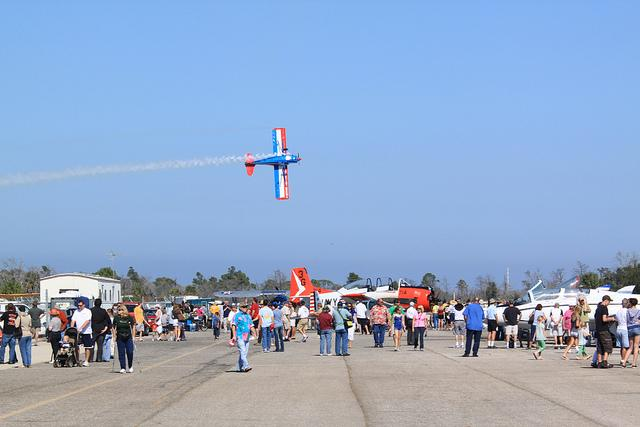Who will be riding those planes?

Choices:
A) airforce
B) animals
C) passengers
D) stunt pilots stunt pilots 